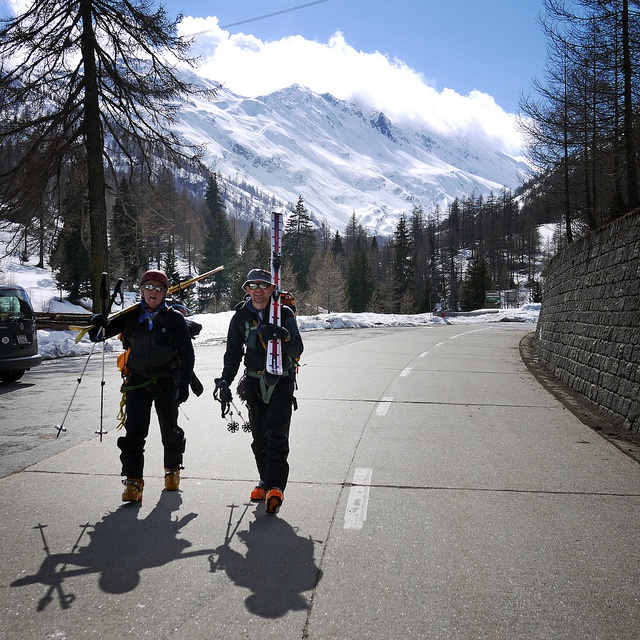Describe the objects in this image and their specific colors. I can see people in lightblue, black, maroon, lightgray, and gray tones, people in lightblue, black, lightgray, gray, and maroon tones, car in lightblue, black, gray, and darkgray tones, skis in lightblue, black, darkgray, and gray tones, and skis in lightblue, black, olive, white, and maroon tones in this image. 